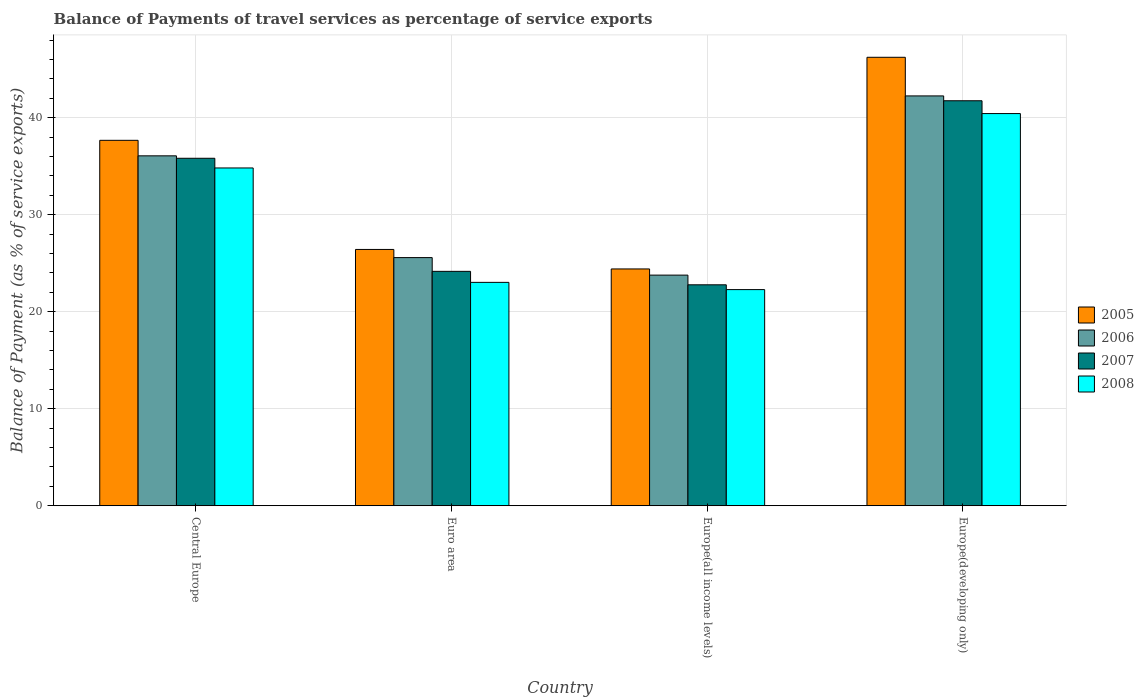How many different coloured bars are there?
Provide a succinct answer. 4. How many bars are there on the 1st tick from the left?
Ensure brevity in your answer.  4. How many bars are there on the 3rd tick from the right?
Ensure brevity in your answer.  4. What is the label of the 4th group of bars from the left?
Your response must be concise. Europe(developing only). What is the balance of payments of travel services in 2008 in Central Europe?
Provide a succinct answer. 34.83. Across all countries, what is the maximum balance of payments of travel services in 2005?
Keep it short and to the point. 46.24. Across all countries, what is the minimum balance of payments of travel services in 2008?
Offer a very short reply. 22.28. In which country was the balance of payments of travel services in 2008 maximum?
Keep it short and to the point. Europe(developing only). In which country was the balance of payments of travel services in 2005 minimum?
Provide a succinct answer. Europe(all income levels). What is the total balance of payments of travel services in 2005 in the graph?
Offer a terse response. 134.75. What is the difference between the balance of payments of travel services in 2005 in Central Europe and that in Europe(developing only)?
Your answer should be compact. -8.56. What is the difference between the balance of payments of travel services in 2007 in Europe(all income levels) and the balance of payments of travel services in 2008 in Central Europe?
Your answer should be compact. -12.05. What is the average balance of payments of travel services in 2006 per country?
Offer a terse response. 31.92. What is the difference between the balance of payments of travel services of/in 2007 and balance of payments of travel services of/in 2005 in Europe(all income levels)?
Offer a very short reply. -1.64. What is the ratio of the balance of payments of travel services in 2008 in Euro area to that in Europe(developing only)?
Your response must be concise. 0.57. What is the difference between the highest and the second highest balance of payments of travel services in 2005?
Offer a very short reply. -11.25. What is the difference between the highest and the lowest balance of payments of travel services in 2006?
Give a very brief answer. 18.48. In how many countries, is the balance of payments of travel services in 2005 greater than the average balance of payments of travel services in 2005 taken over all countries?
Provide a succinct answer. 2. Is the sum of the balance of payments of travel services in 2006 in Europe(all income levels) and Europe(developing only) greater than the maximum balance of payments of travel services in 2008 across all countries?
Offer a very short reply. Yes. What does the 1st bar from the left in Euro area represents?
Provide a short and direct response. 2005. What does the 1st bar from the right in Euro area represents?
Offer a terse response. 2008. Is it the case that in every country, the sum of the balance of payments of travel services in 2006 and balance of payments of travel services in 2007 is greater than the balance of payments of travel services in 2005?
Your answer should be compact. Yes. How many bars are there?
Your answer should be very brief. 16. Are all the bars in the graph horizontal?
Make the answer very short. No. What is the difference between two consecutive major ticks on the Y-axis?
Offer a very short reply. 10. Does the graph contain any zero values?
Your response must be concise. No. Does the graph contain grids?
Your answer should be compact. Yes. Where does the legend appear in the graph?
Your response must be concise. Center right. How many legend labels are there?
Your response must be concise. 4. What is the title of the graph?
Provide a succinct answer. Balance of Payments of travel services as percentage of service exports. Does "2013" appear as one of the legend labels in the graph?
Make the answer very short. No. What is the label or title of the X-axis?
Offer a very short reply. Country. What is the label or title of the Y-axis?
Your answer should be compact. Balance of Payment (as % of service exports). What is the Balance of Payment (as % of service exports) of 2005 in Central Europe?
Give a very brief answer. 37.68. What is the Balance of Payment (as % of service exports) of 2006 in Central Europe?
Give a very brief answer. 36.08. What is the Balance of Payment (as % of service exports) in 2007 in Central Europe?
Provide a short and direct response. 35.83. What is the Balance of Payment (as % of service exports) in 2008 in Central Europe?
Offer a terse response. 34.83. What is the Balance of Payment (as % of service exports) of 2005 in Euro area?
Your answer should be compact. 26.42. What is the Balance of Payment (as % of service exports) of 2006 in Euro area?
Your answer should be compact. 25.58. What is the Balance of Payment (as % of service exports) of 2007 in Euro area?
Offer a terse response. 24.17. What is the Balance of Payment (as % of service exports) of 2008 in Euro area?
Your answer should be compact. 23.03. What is the Balance of Payment (as % of service exports) of 2005 in Europe(all income levels)?
Keep it short and to the point. 24.41. What is the Balance of Payment (as % of service exports) in 2006 in Europe(all income levels)?
Ensure brevity in your answer.  23.78. What is the Balance of Payment (as % of service exports) of 2007 in Europe(all income levels)?
Make the answer very short. 22.78. What is the Balance of Payment (as % of service exports) of 2008 in Europe(all income levels)?
Your response must be concise. 22.28. What is the Balance of Payment (as % of service exports) in 2005 in Europe(developing only)?
Your answer should be compact. 46.24. What is the Balance of Payment (as % of service exports) in 2006 in Europe(developing only)?
Provide a short and direct response. 42.25. What is the Balance of Payment (as % of service exports) in 2007 in Europe(developing only)?
Make the answer very short. 41.76. What is the Balance of Payment (as % of service exports) in 2008 in Europe(developing only)?
Keep it short and to the point. 40.43. Across all countries, what is the maximum Balance of Payment (as % of service exports) of 2005?
Your answer should be very brief. 46.24. Across all countries, what is the maximum Balance of Payment (as % of service exports) in 2006?
Ensure brevity in your answer.  42.25. Across all countries, what is the maximum Balance of Payment (as % of service exports) of 2007?
Your response must be concise. 41.76. Across all countries, what is the maximum Balance of Payment (as % of service exports) of 2008?
Your response must be concise. 40.43. Across all countries, what is the minimum Balance of Payment (as % of service exports) in 2005?
Give a very brief answer. 24.41. Across all countries, what is the minimum Balance of Payment (as % of service exports) of 2006?
Make the answer very short. 23.78. Across all countries, what is the minimum Balance of Payment (as % of service exports) of 2007?
Give a very brief answer. 22.78. Across all countries, what is the minimum Balance of Payment (as % of service exports) in 2008?
Give a very brief answer. 22.28. What is the total Balance of Payment (as % of service exports) of 2005 in the graph?
Keep it short and to the point. 134.75. What is the total Balance of Payment (as % of service exports) in 2006 in the graph?
Provide a succinct answer. 127.69. What is the total Balance of Payment (as % of service exports) of 2007 in the graph?
Provide a succinct answer. 124.52. What is the total Balance of Payment (as % of service exports) of 2008 in the graph?
Your answer should be compact. 120.57. What is the difference between the Balance of Payment (as % of service exports) in 2005 in Central Europe and that in Euro area?
Provide a succinct answer. 11.25. What is the difference between the Balance of Payment (as % of service exports) of 2006 in Central Europe and that in Euro area?
Ensure brevity in your answer.  10.49. What is the difference between the Balance of Payment (as % of service exports) in 2007 in Central Europe and that in Euro area?
Provide a short and direct response. 11.66. What is the difference between the Balance of Payment (as % of service exports) in 2008 in Central Europe and that in Euro area?
Make the answer very short. 11.8. What is the difference between the Balance of Payment (as % of service exports) of 2005 in Central Europe and that in Europe(all income levels)?
Offer a very short reply. 13.26. What is the difference between the Balance of Payment (as % of service exports) in 2006 in Central Europe and that in Europe(all income levels)?
Provide a short and direct response. 12.3. What is the difference between the Balance of Payment (as % of service exports) of 2007 in Central Europe and that in Europe(all income levels)?
Your response must be concise. 13.05. What is the difference between the Balance of Payment (as % of service exports) of 2008 in Central Europe and that in Europe(all income levels)?
Offer a very short reply. 12.54. What is the difference between the Balance of Payment (as % of service exports) in 2005 in Central Europe and that in Europe(developing only)?
Keep it short and to the point. -8.56. What is the difference between the Balance of Payment (as % of service exports) of 2006 in Central Europe and that in Europe(developing only)?
Give a very brief answer. -6.18. What is the difference between the Balance of Payment (as % of service exports) in 2007 in Central Europe and that in Europe(developing only)?
Your answer should be compact. -5.93. What is the difference between the Balance of Payment (as % of service exports) of 2008 in Central Europe and that in Europe(developing only)?
Provide a short and direct response. -5.61. What is the difference between the Balance of Payment (as % of service exports) in 2005 in Euro area and that in Europe(all income levels)?
Ensure brevity in your answer.  2.01. What is the difference between the Balance of Payment (as % of service exports) in 2006 in Euro area and that in Europe(all income levels)?
Make the answer very short. 1.81. What is the difference between the Balance of Payment (as % of service exports) of 2007 in Euro area and that in Europe(all income levels)?
Your answer should be compact. 1.39. What is the difference between the Balance of Payment (as % of service exports) in 2008 in Euro area and that in Europe(all income levels)?
Give a very brief answer. 0.75. What is the difference between the Balance of Payment (as % of service exports) of 2005 in Euro area and that in Europe(developing only)?
Offer a very short reply. -19.81. What is the difference between the Balance of Payment (as % of service exports) of 2006 in Euro area and that in Europe(developing only)?
Your response must be concise. -16.67. What is the difference between the Balance of Payment (as % of service exports) in 2007 in Euro area and that in Europe(developing only)?
Offer a very short reply. -17.59. What is the difference between the Balance of Payment (as % of service exports) of 2008 in Euro area and that in Europe(developing only)?
Offer a terse response. -17.41. What is the difference between the Balance of Payment (as % of service exports) in 2005 in Europe(all income levels) and that in Europe(developing only)?
Provide a short and direct response. -21.82. What is the difference between the Balance of Payment (as % of service exports) in 2006 in Europe(all income levels) and that in Europe(developing only)?
Your answer should be very brief. -18.48. What is the difference between the Balance of Payment (as % of service exports) in 2007 in Europe(all income levels) and that in Europe(developing only)?
Ensure brevity in your answer.  -18.98. What is the difference between the Balance of Payment (as % of service exports) of 2008 in Europe(all income levels) and that in Europe(developing only)?
Provide a succinct answer. -18.15. What is the difference between the Balance of Payment (as % of service exports) of 2005 in Central Europe and the Balance of Payment (as % of service exports) of 2006 in Euro area?
Offer a very short reply. 12.09. What is the difference between the Balance of Payment (as % of service exports) of 2005 in Central Europe and the Balance of Payment (as % of service exports) of 2007 in Euro area?
Ensure brevity in your answer.  13.51. What is the difference between the Balance of Payment (as % of service exports) of 2005 in Central Europe and the Balance of Payment (as % of service exports) of 2008 in Euro area?
Provide a succinct answer. 14.65. What is the difference between the Balance of Payment (as % of service exports) in 2006 in Central Europe and the Balance of Payment (as % of service exports) in 2007 in Euro area?
Your answer should be very brief. 11.91. What is the difference between the Balance of Payment (as % of service exports) in 2006 in Central Europe and the Balance of Payment (as % of service exports) in 2008 in Euro area?
Offer a terse response. 13.05. What is the difference between the Balance of Payment (as % of service exports) in 2007 in Central Europe and the Balance of Payment (as % of service exports) in 2008 in Euro area?
Keep it short and to the point. 12.8. What is the difference between the Balance of Payment (as % of service exports) in 2005 in Central Europe and the Balance of Payment (as % of service exports) in 2006 in Europe(all income levels)?
Ensure brevity in your answer.  13.9. What is the difference between the Balance of Payment (as % of service exports) of 2005 in Central Europe and the Balance of Payment (as % of service exports) of 2007 in Europe(all income levels)?
Provide a succinct answer. 14.9. What is the difference between the Balance of Payment (as % of service exports) in 2005 in Central Europe and the Balance of Payment (as % of service exports) in 2008 in Europe(all income levels)?
Your answer should be compact. 15.39. What is the difference between the Balance of Payment (as % of service exports) in 2006 in Central Europe and the Balance of Payment (as % of service exports) in 2007 in Europe(all income levels)?
Offer a terse response. 13.3. What is the difference between the Balance of Payment (as % of service exports) in 2006 in Central Europe and the Balance of Payment (as % of service exports) in 2008 in Europe(all income levels)?
Make the answer very short. 13.79. What is the difference between the Balance of Payment (as % of service exports) of 2007 in Central Europe and the Balance of Payment (as % of service exports) of 2008 in Europe(all income levels)?
Make the answer very short. 13.54. What is the difference between the Balance of Payment (as % of service exports) of 2005 in Central Europe and the Balance of Payment (as % of service exports) of 2006 in Europe(developing only)?
Provide a short and direct response. -4.58. What is the difference between the Balance of Payment (as % of service exports) in 2005 in Central Europe and the Balance of Payment (as % of service exports) in 2007 in Europe(developing only)?
Provide a short and direct response. -4.08. What is the difference between the Balance of Payment (as % of service exports) of 2005 in Central Europe and the Balance of Payment (as % of service exports) of 2008 in Europe(developing only)?
Offer a very short reply. -2.76. What is the difference between the Balance of Payment (as % of service exports) of 2006 in Central Europe and the Balance of Payment (as % of service exports) of 2007 in Europe(developing only)?
Your answer should be compact. -5.68. What is the difference between the Balance of Payment (as % of service exports) in 2006 in Central Europe and the Balance of Payment (as % of service exports) in 2008 in Europe(developing only)?
Offer a very short reply. -4.36. What is the difference between the Balance of Payment (as % of service exports) in 2007 in Central Europe and the Balance of Payment (as % of service exports) in 2008 in Europe(developing only)?
Ensure brevity in your answer.  -4.61. What is the difference between the Balance of Payment (as % of service exports) in 2005 in Euro area and the Balance of Payment (as % of service exports) in 2006 in Europe(all income levels)?
Give a very brief answer. 2.65. What is the difference between the Balance of Payment (as % of service exports) of 2005 in Euro area and the Balance of Payment (as % of service exports) of 2007 in Europe(all income levels)?
Provide a succinct answer. 3.65. What is the difference between the Balance of Payment (as % of service exports) of 2005 in Euro area and the Balance of Payment (as % of service exports) of 2008 in Europe(all income levels)?
Give a very brief answer. 4.14. What is the difference between the Balance of Payment (as % of service exports) of 2006 in Euro area and the Balance of Payment (as % of service exports) of 2007 in Europe(all income levels)?
Provide a short and direct response. 2.81. What is the difference between the Balance of Payment (as % of service exports) in 2006 in Euro area and the Balance of Payment (as % of service exports) in 2008 in Europe(all income levels)?
Offer a terse response. 3.3. What is the difference between the Balance of Payment (as % of service exports) in 2007 in Euro area and the Balance of Payment (as % of service exports) in 2008 in Europe(all income levels)?
Provide a short and direct response. 1.88. What is the difference between the Balance of Payment (as % of service exports) of 2005 in Euro area and the Balance of Payment (as % of service exports) of 2006 in Europe(developing only)?
Make the answer very short. -15.83. What is the difference between the Balance of Payment (as % of service exports) in 2005 in Euro area and the Balance of Payment (as % of service exports) in 2007 in Europe(developing only)?
Offer a terse response. -15.33. What is the difference between the Balance of Payment (as % of service exports) in 2005 in Euro area and the Balance of Payment (as % of service exports) in 2008 in Europe(developing only)?
Give a very brief answer. -14.01. What is the difference between the Balance of Payment (as % of service exports) of 2006 in Euro area and the Balance of Payment (as % of service exports) of 2007 in Europe(developing only)?
Offer a very short reply. -16.17. What is the difference between the Balance of Payment (as % of service exports) in 2006 in Euro area and the Balance of Payment (as % of service exports) in 2008 in Europe(developing only)?
Offer a terse response. -14.85. What is the difference between the Balance of Payment (as % of service exports) of 2007 in Euro area and the Balance of Payment (as % of service exports) of 2008 in Europe(developing only)?
Your answer should be compact. -16.27. What is the difference between the Balance of Payment (as % of service exports) of 2005 in Europe(all income levels) and the Balance of Payment (as % of service exports) of 2006 in Europe(developing only)?
Offer a very short reply. -17.84. What is the difference between the Balance of Payment (as % of service exports) in 2005 in Europe(all income levels) and the Balance of Payment (as % of service exports) in 2007 in Europe(developing only)?
Your response must be concise. -17.34. What is the difference between the Balance of Payment (as % of service exports) in 2005 in Europe(all income levels) and the Balance of Payment (as % of service exports) in 2008 in Europe(developing only)?
Provide a short and direct response. -16.02. What is the difference between the Balance of Payment (as % of service exports) in 2006 in Europe(all income levels) and the Balance of Payment (as % of service exports) in 2007 in Europe(developing only)?
Ensure brevity in your answer.  -17.98. What is the difference between the Balance of Payment (as % of service exports) of 2006 in Europe(all income levels) and the Balance of Payment (as % of service exports) of 2008 in Europe(developing only)?
Give a very brief answer. -16.66. What is the difference between the Balance of Payment (as % of service exports) of 2007 in Europe(all income levels) and the Balance of Payment (as % of service exports) of 2008 in Europe(developing only)?
Offer a terse response. -17.66. What is the average Balance of Payment (as % of service exports) of 2005 per country?
Your answer should be very brief. 33.69. What is the average Balance of Payment (as % of service exports) in 2006 per country?
Your answer should be compact. 31.92. What is the average Balance of Payment (as % of service exports) of 2007 per country?
Offer a very short reply. 31.13. What is the average Balance of Payment (as % of service exports) of 2008 per country?
Make the answer very short. 30.14. What is the difference between the Balance of Payment (as % of service exports) of 2005 and Balance of Payment (as % of service exports) of 2006 in Central Europe?
Your answer should be very brief. 1.6. What is the difference between the Balance of Payment (as % of service exports) of 2005 and Balance of Payment (as % of service exports) of 2007 in Central Europe?
Provide a succinct answer. 1.85. What is the difference between the Balance of Payment (as % of service exports) in 2005 and Balance of Payment (as % of service exports) in 2008 in Central Europe?
Keep it short and to the point. 2.85. What is the difference between the Balance of Payment (as % of service exports) of 2006 and Balance of Payment (as % of service exports) of 2007 in Central Europe?
Your answer should be very brief. 0.25. What is the difference between the Balance of Payment (as % of service exports) of 2006 and Balance of Payment (as % of service exports) of 2008 in Central Europe?
Your answer should be compact. 1.25. What is the difference between the Balance of Payment (as % of service exports) of 2005 and Balance of Payment (as % of service exports) of 2006 in Euro area?
Provide a succinct answer. 0.84. What is the difference between the Balance of Payment (as % of service exports) of 2005 and Balance of Payment (as % of service exports) of 2007 in Euro area?
Keep it short and to the point. 2.26. What is the difference between the Balance of Payment (as % of service exports) of 2005 and Balance of Payment (as % of service exports) of 2008 in Euro area?
Keep it short and to the point. 3.4. What is the difference between the Balance of Payment (as % of service exports) in 2006 and Balance of Payment (as % of service exports) in 2007 in Euro area?
Offer a very short reply. 1.42. What is the difference between the Balance of Payment (as % of service exports) of 2006 and Balance of Payment (as % of service exports) of 2008 in Euro area?
Keep it short and to the point. 2.55. What is the difference between the Balance of Payment (as % of service exports) of 2007 and Balance of Payment (as % of service exports) of 2008 in Euro area?
Provide a short and direct response. 1.14. What is the difference between the Balance of Payment (as % of service exports) of 2005 and Balance of Payment (as % of service exports) of 2006 in Europe(all income levels)?
Offer a terse response. 0.64. What is the difference between the Balance of Payment (as % of service exports) of 2005 and Balance of Payment (as % of service exports) of 2007 in Europe(all income levels)?
Your response must be concise. 1.64. What is the difference between the Balance of Payment (as % of service exports) of 2005 and Balance of Payment (as % of service exports) of 2008 in Europe(all income levels)?
Your answer should be very brief. 2.13. What is the difference between the Balance of Payment (as % of service exports) in 2006 and Balance of Payment (as % of service exports) in 2008 in Europe(all income levels)?
Your response must be concise. 1.49. What is the difference between the Balance of Payment (as % of service exports) in 2007 and Balance of Payment (as % of service exports) in 2008 in Europe(all income levels)?
Keep it short and to the point. 0.49. What is the difference between the Balance of Payment (as % of service exports) in 2005 and Balance of Payment (as % of service exports) in 2006 in Europe(developing only)?
Your answer should be very brief. 3.98. What is the difference between the Balance of Payment (as % of service exports) of 2005 and Balance of Payment (as % of service exports) of 2007 in Europe(developing only)?
Your response must be concise. 4.48. What is the difference between the Balance of Payment (as % of service exports) of 2005 and Balance of Payment (as % of service exports) of 2008 in Europe(developing only)?
Provide a succinct answer. 5.8. What is the difference between the Balance of Payment (as % of service exports) of 2006 and Balance of Payment (as % of service exports) of 2007 in Europe(developing only)?
Keep it short and to the point. 0.5. What is the difference between the Balance of Payment (as % of service exports) in 2006 and Balance of Payment (as % of service exports) in 2008 in Europe(developing only)?
Offer a very short reply. 1.82. What is the difference between the Balance of Payment (as % of service exports) in 2007 and Balance of Payment (as % of service exports) in 2008 in Europe(developing only)?
Offer a very short reply. 1.32. What is the ratio of the Balance of Payment (as % of service exports) in 2005 in Central Europe to that in Euro area?
Make the answer very short. 1.43. What is the ratio of the Balance of Payment (as % of service exports) of 2006 in Central Europe to that in Euro area?
Provide a short and direct response. 1.41. What is the ratio of the Balance of Payment (as % of service exports) in 2007 in Central Europe to that in Euro area?
Keep it short and to the point. 1.48. What is the ratio of the Balance of Payment (as % of service exports) in 2008 in Central Europe to that in Euro area?
Offer a terse response. 1.51. What is the ratio of the Balance of Payment (as % of service exports) in 2005 in Central Europe to that in Europe(all income levels)?
Offer a terse response. 1.54. What is the ratio of the Balance of Payment (as % of service exports) in 2006 in Central Europe to that in Europe(all income levels)?
Your response must be concise. 1.52. What is the ratio of the Balance of Payment (as % of service exports) in 2007 in Central Europe to that in Europe(all income levels)?
Provide a short and direct response. 1.57. What is the ratio of the Balance of Payment (as % of service exports) in 2008 in Central Europe to that in Europe(all income levels)?
Your answer should be compact. 1.56. What is the ratio of the Balance of Payment (as % of service exports) of 2005 in Central Europe to that in Europe(developing only)?
Your response must be concise. 0.81. What is the ratio of the Balance of Payment (as % of service exports) of 2006 in Central Europe to that in Europe(developing only)?
Your response must be concise. 0.85. What is the ratio of the Balance of Payment (as % of service exports) in 2007 in Central Europe to that in Europe(developing only)?
Offer a very short reply. 0.86. What is the ratio of the Balance of Payment (as % of service exports) of 2008 in Central Europe to that in Europe(developing only)?
Offer a very short reply. 0.86. What is the ratio of the Balance of Payment (as % of service exports) in 2005 in Euro area to that in Europe(all income levels)?
Offer a terse response. 1.08. What is the ratio of the Balance of Payment (as % of service exports) of 2006 in Euro area to that in Europe(all income levels)?
Your response must be concise. 1.08. What is the ratio of the Balance of Payment (as % of service exports) of 2007 in Euro area to that in Europe(all income levels)?
Your answer should be compact. 1.06. What is the ratio of the Balance of Payment (as % of service exports) in 2008 in Euro area to that in Europe(all income levels)?
Ensure brevity in your answer.  1.03. What is the ratio of the Balance of Payment (as % of service exports) of 2005 in Euro area to that in Europe(developing only)?
Your answer should be compact. 0.57. What is the ratio of the Balance of Payment (as % of service exports) in 2006 in Euro area to that in Europe(developing only)?
Offer a terse response. 0.61. What is the ratio of the Balance of Payment (as % of service exports) in 2007 in Euro area to that in Europe(developing only)?
Offer a terse response. 0.58. What is the ratio of the Balance of Payment (as % of service exports) of 2008 in Euro area to that in Europe(developing only)?
Offer a very short reply. 0.57. What is the ratio of the Balance of Payment (as % of service exports) in 2005 in Europe(all income levels) to that in Europe(developing only)?
Provide a short and direct response. 0.53. What is the ratio of the Balance of Payment (as % of service exports) of 2006 in Europe(all income levels) to that in Europe(developing only)?
Your response must be concise. 0.56. What is the ratio of the Balance of Payment (as % of service exports) in 2007 in Europe(all income levels) to that in Europe(developing only)?
Your answer should be very brief. 0.55. What is the ratio of the Balance of Payment (as % of service exports) of 2008 in Europe(all income levels) to that in Europe(developing only)?
Make the answer very short. 0.55. What is the difference between the highest and the second highest Balance of Payment (as % of service exports) in 2005?
Your answer should be very brief. 8.56. What is the difference between the highest and the second highest Balance of Payment (as % of service exports) in 2006?
Ensure brevity in your answer.  6.18. What is the difference between the highest and the second highest Balance of Payment (as % of service exports) in 2007?
Offer a terse response. 5.93. What is the difference between the highest and the second highest Balance of Payment (as % of service exports) in 2008?
Make the answer very short. 5.61. What is the difference between the highest and the lowest Balance of Payment (as % of service exports) of 2005?
Your answer should be compact. 21.82. What is the difference between the highest and the lowest Balance of Payment (as % of service exports) in 2006?
Offer a terse response. 18.48. What is the difference between the highest and the lowest Balance of Payment (as % of service exports) in 2007?
Offer a terse response. 18.98. What is the difference between the highest and the lowest Balance of Payment (as % of service exports) in 2008?
Provide a succinct answer. 18.15. 